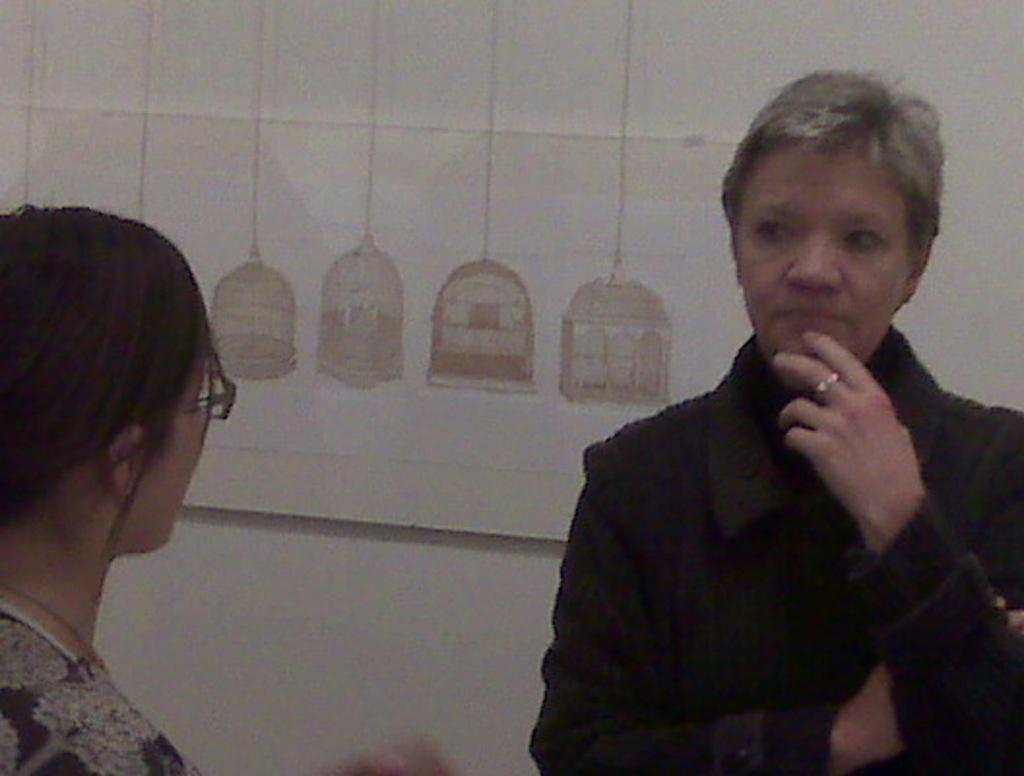How many people are in the image? There are two women in the image. What are the women doing in the image? The women are facing each other. Is there any artwork visible in the image? Yes, there is a painting on a wall in the image. What type of writing can be seen on the tent in the image? There is no tent present in the image, so there is no writing on a tent to be observed. 